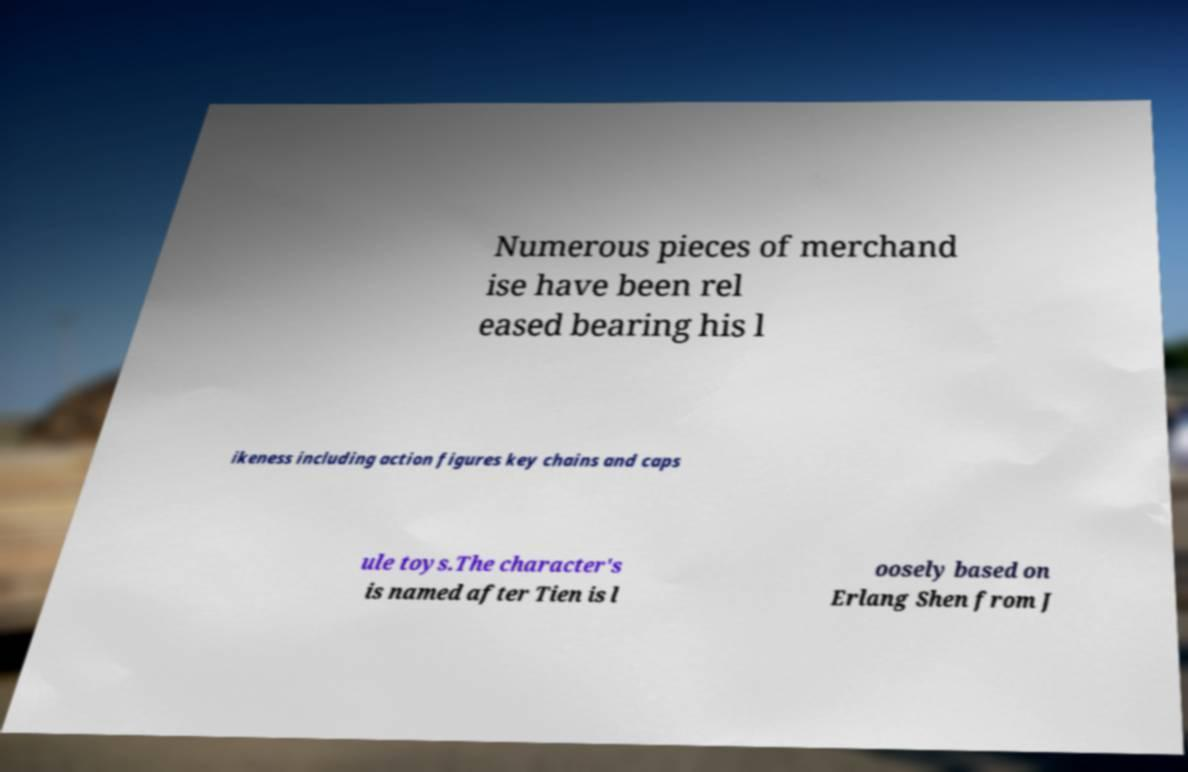Please read and relay the text visible in this image. What does it say? Numerous pieces of merchand ise have been rel eased bearing his l ikeness including action figures key chains and caps ule toys.The character's is named after Tien is l oosely based on Erlang Shen from J 